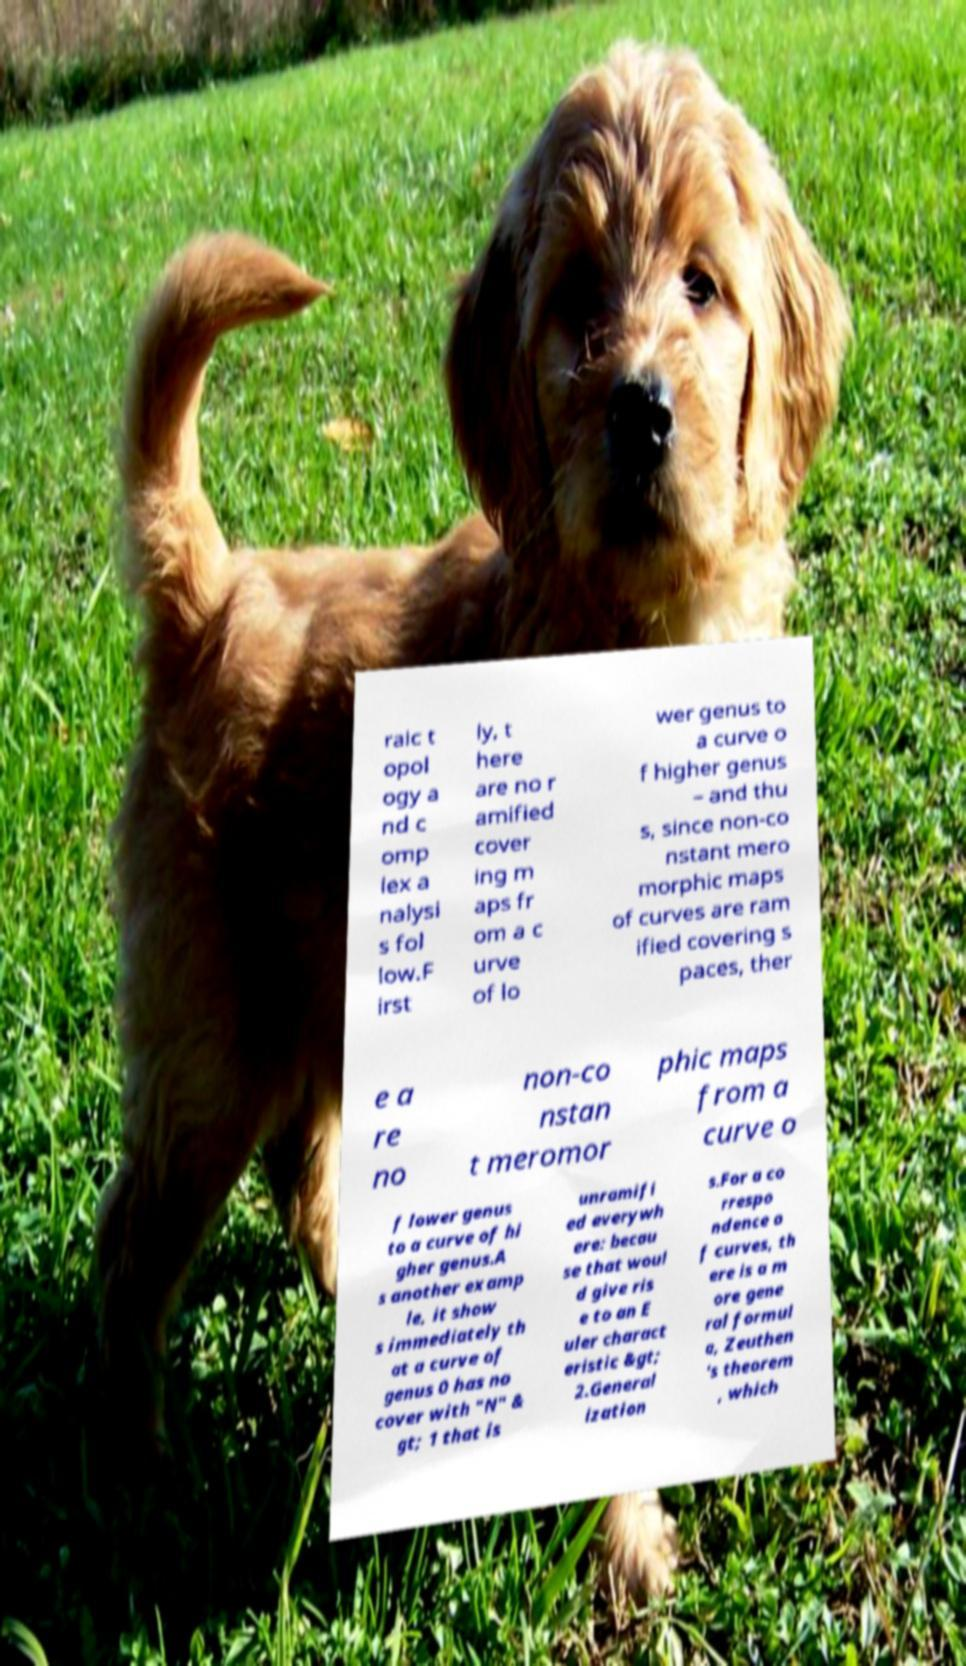I need the written content from this picture converted into text. Can you do that? raic t opol ogy a nd c omp lex a nalysi s fol low.F irst ly, t here are no r amified cover ing m aps fr om a c urve of lo wer genus to a curve o f higher genus – and thu s, since non-co nstant mero morphic maps of curves are ram ified covering s paces, ther e a re no non-co nstan t meromor phic maps from a curve o f lower genus to a curve of hi gher genus.A s another examp le, it show s immediately th at a curve of genus 0 has no cover with "N" & gt; 1 that is unramifi ed everywh ere: becau se that woul d give ris e to an E uler charact eristic &gt; 2.General ization s.For a co rrespo ndence o f curves, th ere is a m ore gene ral formul a, Zeuthen 's theorem , which 